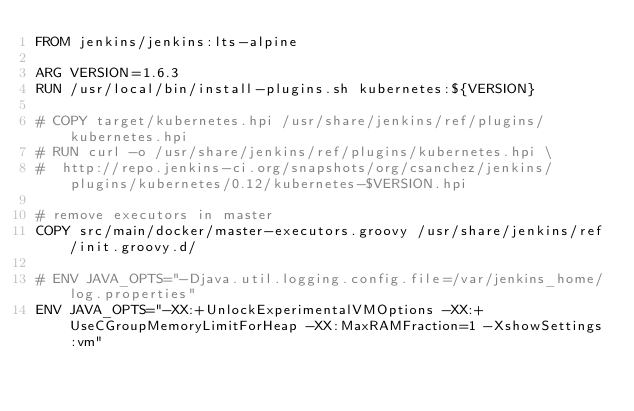Convert code to text. <code><loc_0><loc_0><loc_500><loc_500><_Dockerfile_>FROM jenkins/jenkins:lts-alpine

ARG VERSION=1.6.3
RUN /usr/local/bin/install-plugins.sh kubernetes:${VERSION}

# COPY target/kubernetes.hpi /usr/share/jenkins/ref/plugins/kubernetes.hpi
# RUN curl -o /usr/share/jenkins/ref/plugins/kubernetes.hpi \
#  http://repo.jenkins-ci.org/snapshots/org/csanchez/jenkins/plugins/kubernetes/0.12/kubernetes-$VERSION.hpi

# remove executors in master
COPY src/main/docker/master-executors.groovy /usr/share/jenkins/ref/init.groovy.d/

# ENV JAVA_OPTS="-Djava.util.logging.config.file=/var/jenkins_home/log.properties"
ENV JAVA_OPTS="-XX:+UnlockExperimentalVMOptions -XX:+UseCGroupMemoryLimitForHeap -XX:MaxRAMFraction=1 -XshowSettings:vm"
</code> 